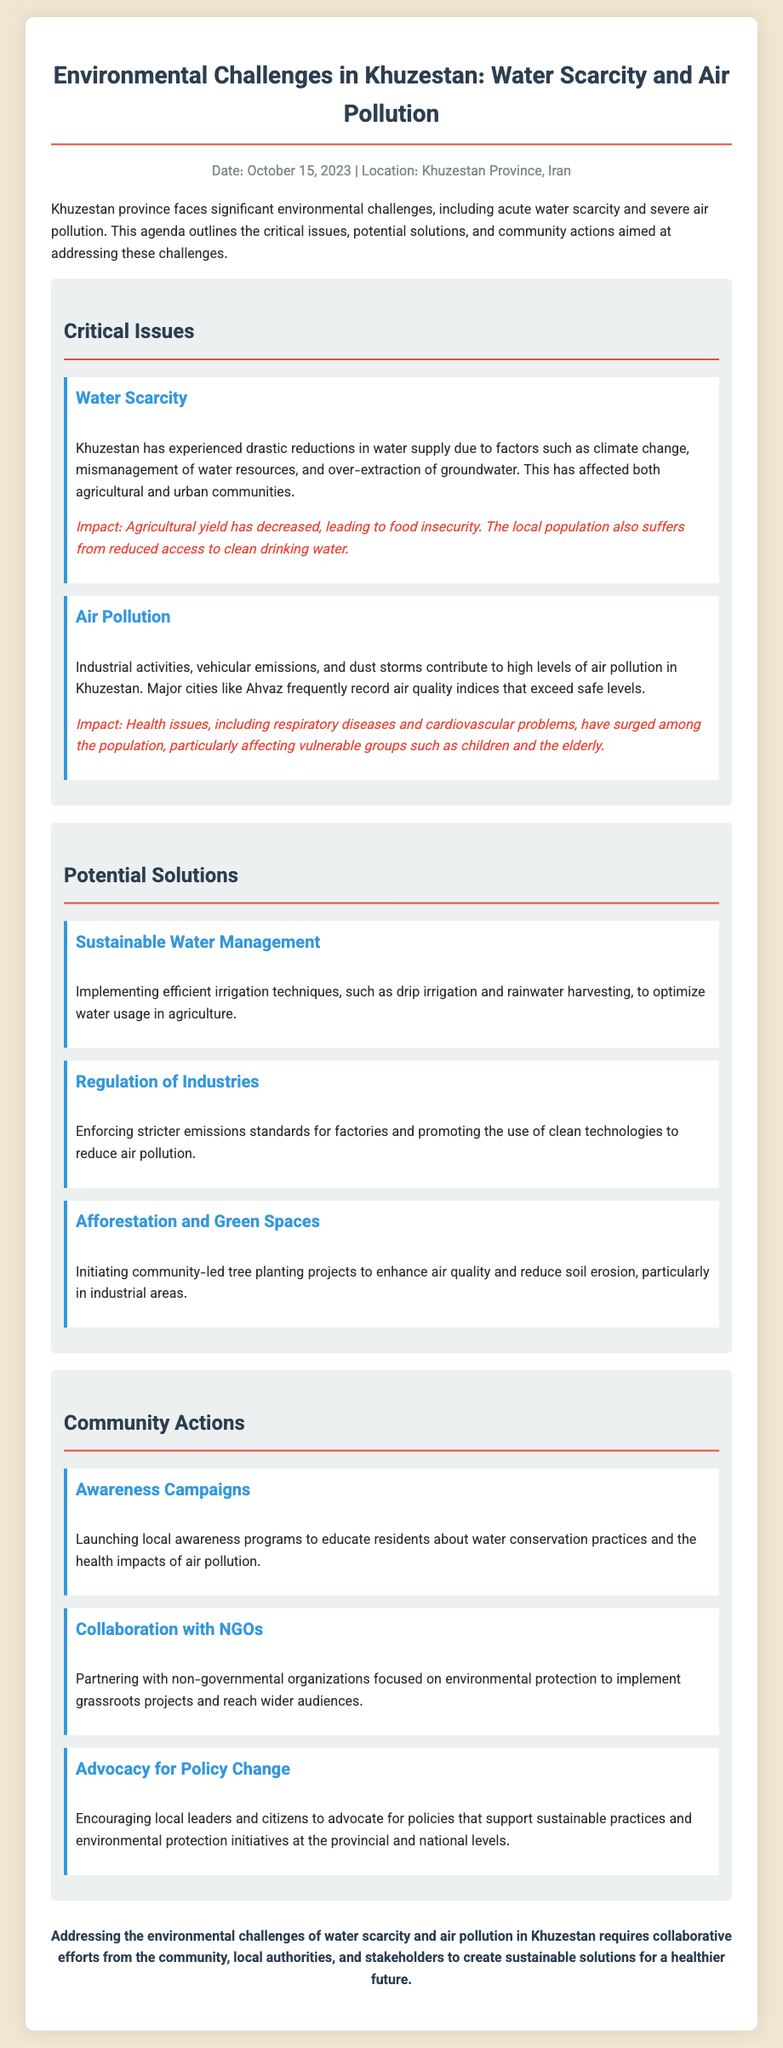what are the two main environmental challenges in Khuzestan? The document states that the two main challenges are water scarcity and air pollution.
Answer: water scarcity and air pollution what date was the agenda published? The document mentions the publication date as October 15, 2023.
Answer: October 15, 2023 which city in Khuzestan frequently records unsafe air quality levels? The document specifies that Ahvaz frequently records air quality indices that exceed safe levels.
Answer: Ahvaz what impact does water scarcity have on the agricultural yield? The document notes that agricultural yield has decreased, leading to food insecurity due to water scarcity.
Answer: decreased what is one potential solution for air pollution mentioned in the document? The document lists the regulation of industries as one potential solution for air pollution.
Answer: regulation of industries how can the community contribute to improving air quality? The document mentions community-led tree planting projects as a way to enhance air quality.
Answer: tree planting projects what role do NGOs play according to the agenda? The document states that NGOs are involved in partnering with local efforts for environmental protection and projects.
Answer: environmental protection what is a recommended action to raise awareness about environmental issues? The document suggests launching local awareness programs to educate residents about water conservation and health impacts.
Answer: awareness programs what method for water management does the document advocate? The document proposes implementing efficient irrigation techniques, such as drip irrigation and rainwater harvesting.
Answer: drip irrigation and rainwater harvesting 